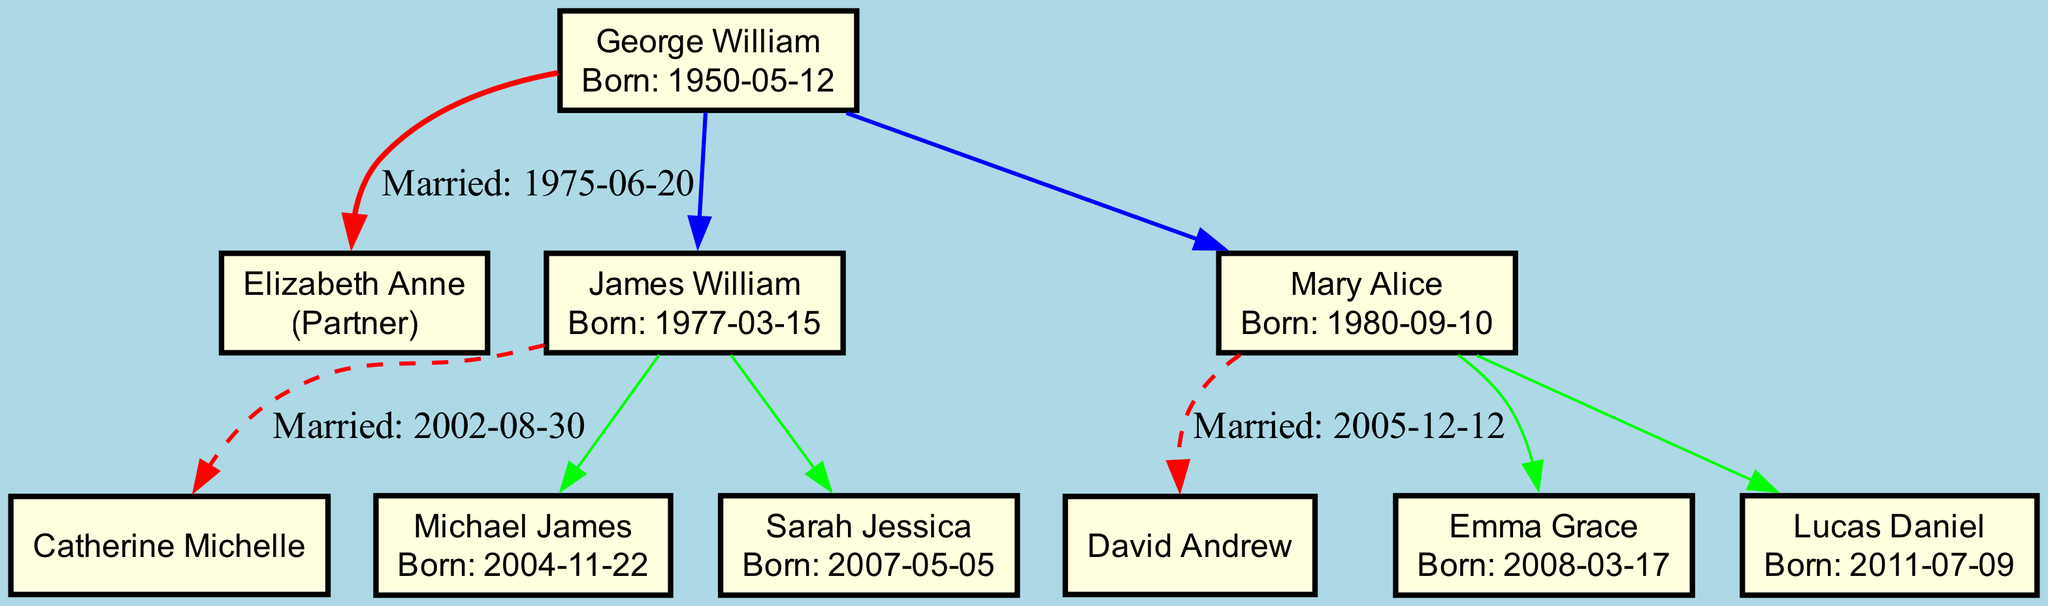What is the birth date of George William? The birth date of George William is explicitly noted in the diagram as "1950-05-12".
Answer: 1950-05-12 How many children does George William have? The diagram lists two children under George William: James William and Mary Alice, indicating that he has a total of two children.
Answer: 2 Who is George William's partner? The diagram shows that George William's partner is Elizabeth Anne, displayed just below his name on the diagram.
Answer: Elizabeth Anne When did James William get married? The diagram indicates that James William got married on "2002-08-30" alongside his name, detailing his marriage event.
Answer: 2002-08-30 What are the names of James William's children? The diagram lists the names of James William's children as Michael James and Sarah Jessica, shown under his section in the family tree.
Answer: Michael James, Sarah Jessica Who is the spouse of Mary Alice? The diagram shows that Mary Alice's spouse is David Andrew, indicated next to her name and connected by a marriage line.
Answer: David Andrew How old was George William when he got married? To find George William's age at his marriage date, we calculate the difference between his birth year (1950) and his marriage year (1975), which gives us 25 years.
Answer: 25 How many grandchildren does George William have? James William has two children (Michael James and Sarah Jessica) and Mary Alice has two children (Emma Grace and Lucas Daniel), totaling four grandchildren altogether for George William.
Answer: 4 What is the birth date of Sarah Jessica? The diagram presents the birth date of Sarah Jessica as "2007-05-05", shown under her name along with her father's information.
Answer: 2007-05-05 